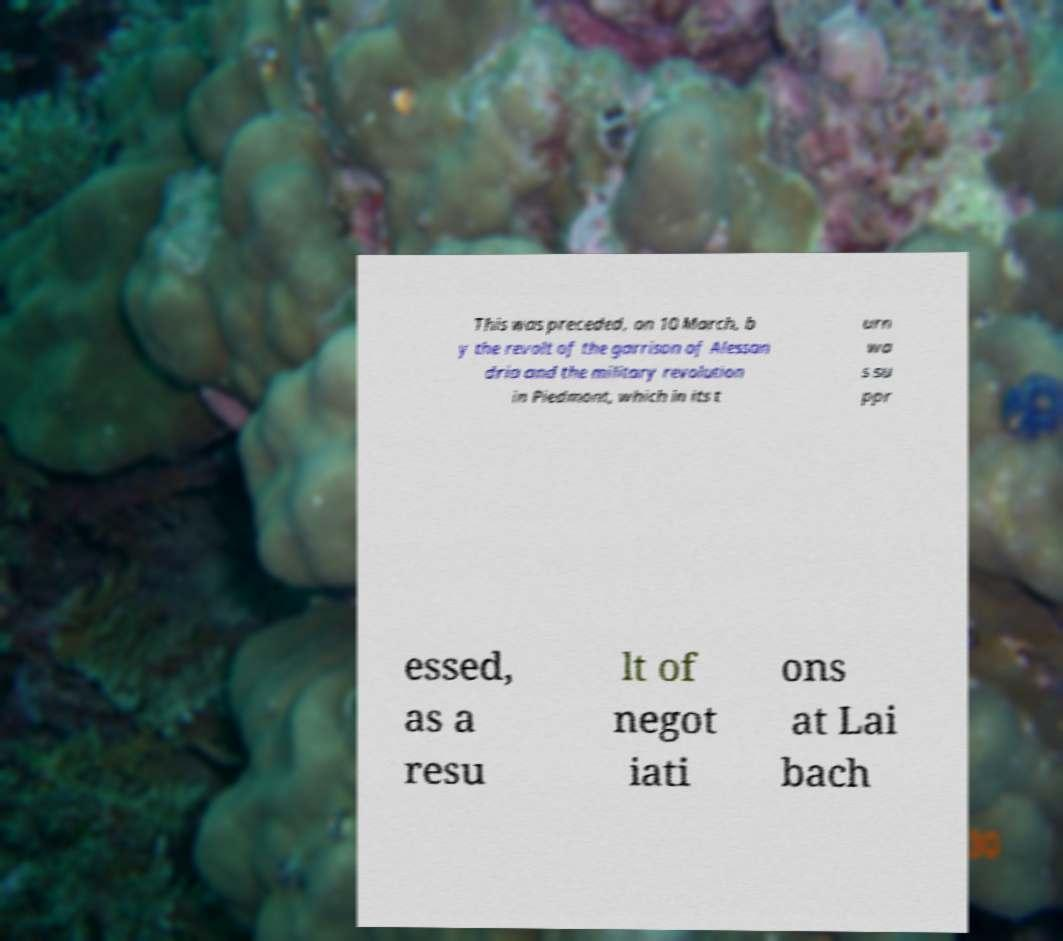For documentation purposes, I need the text within this image transcribed. Could you provide that? This was preceded, on 10 March, b y the revolt of the garrison of Alessan dria and the military revolution in Piedmont, which in its t urn wa s su ppr essed, as a resu lt of negot iati ons at Lai bach 